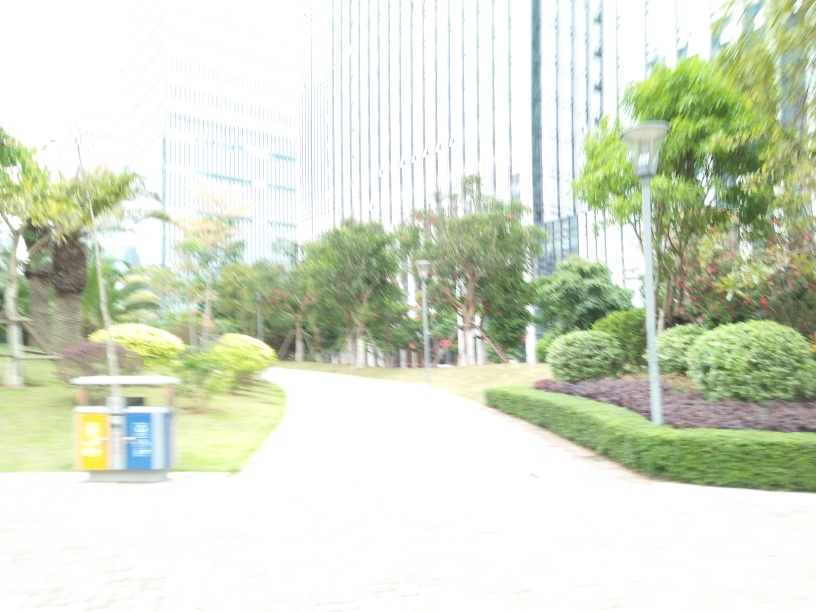What could be done to improve the quality of a photo like this? To improve the image's quality, one could adjust the camera's settings to decrease the exposure, ensuring the light levels are appropriate for the environment. A lower ISO or a faster shutter speed could help capture a clearer and more detailed photograph. 